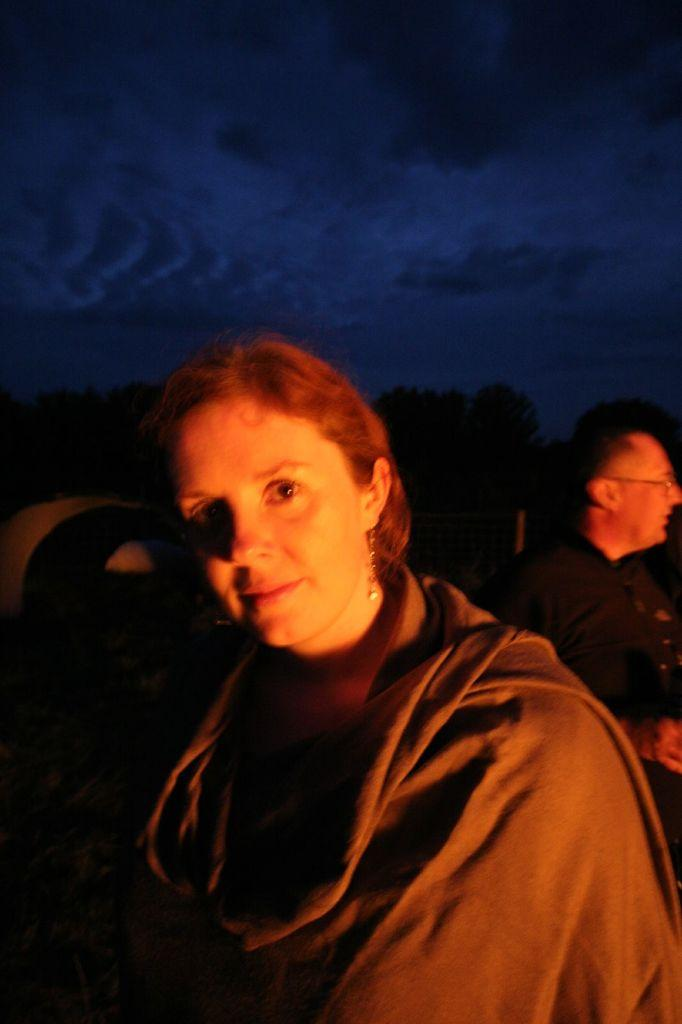Who is present in the image? There is a woman in the image. What is the woman wearing? The woman is wearing a shawl. Can you describe the other person visible in the image? The other person is visible from the back side in the image. What type of top does the grandmother approve of in the image? There is no mention of a grandmother or approval in the image, and no specific type of top is visible. 